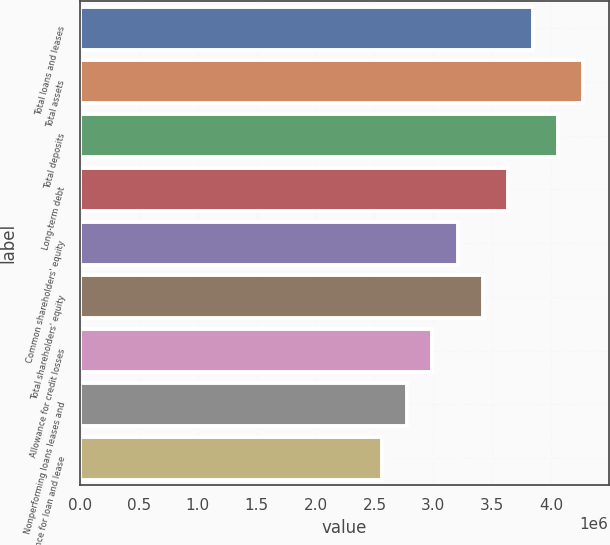<chart> <loc_0><loc_0><loc_500><loc_500><bar_chart><fcel>Total loans and leases<fcel>Total assets<fcel>Total deposits<fcel>Long-term debt<fcel>Common shareholders' equity<fcel>Total shareholders' equity<fcel>Allowance for credit losses<fcel>Nonperforming loans leases and<fcel>Allowance for loan and lease<nl><fcel>3.84759e+06<fcel>4.2751e+06<fcel>4.06135e+06<fcel>3.63384e+06<fcel>3.20633e+06<fcel>3.42008e+06<fcel>2.99257e+06<fcel>2.77882e+06<fcel>2.56506e+06<nl></chart> 